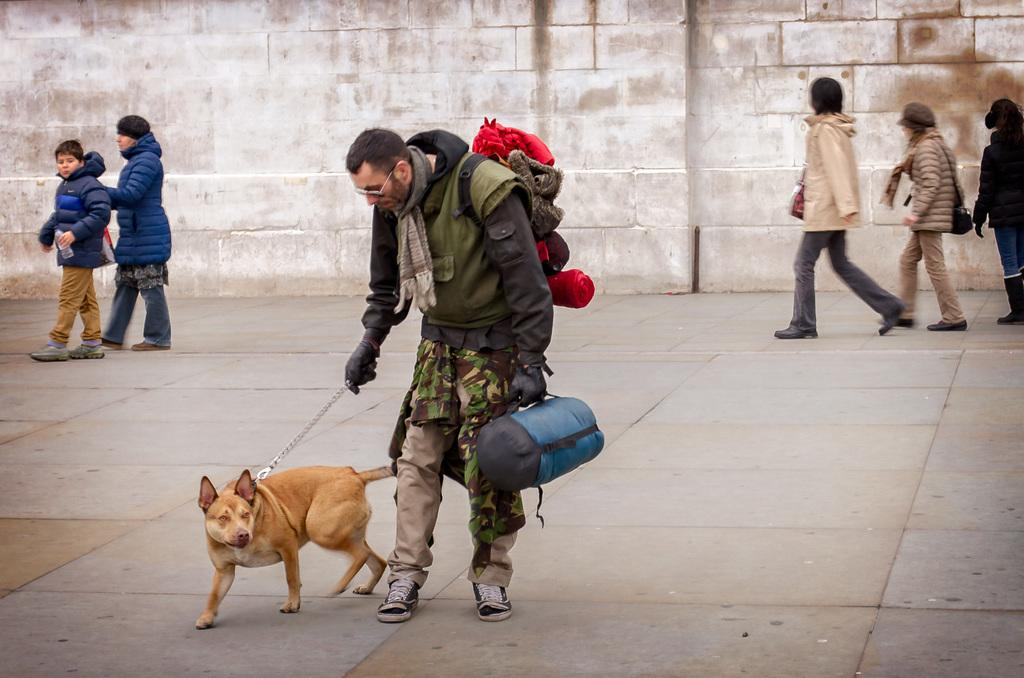Who is the main subject in the image? There is a man in the image. What is the man holding in the image? The man is holding a dog and a bag. What can be seen in the background of the image? There are people walking and a wall in the background of the image. What type of jewel is the man wearing on his thumb in the image? There is no jewel or thumb ring visible on the man's hand in the image. How does the tramp fit into the scene depicted in the image? There is no tramp present in the image; it features a man holding a dog and a bag, with people walking and a wall in the background. 